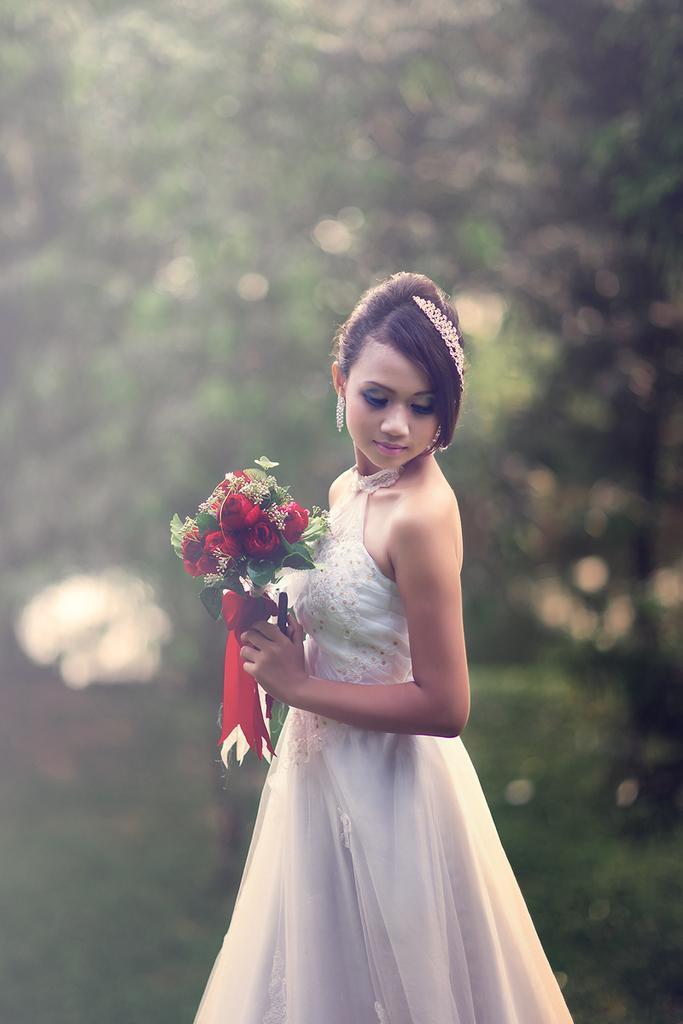In one or two sentences, can you explain what this image depicts? This is the woman holding a flower bouquet in her hands and standing. She wore a white frock. The background looks green in color, which is blurred. 